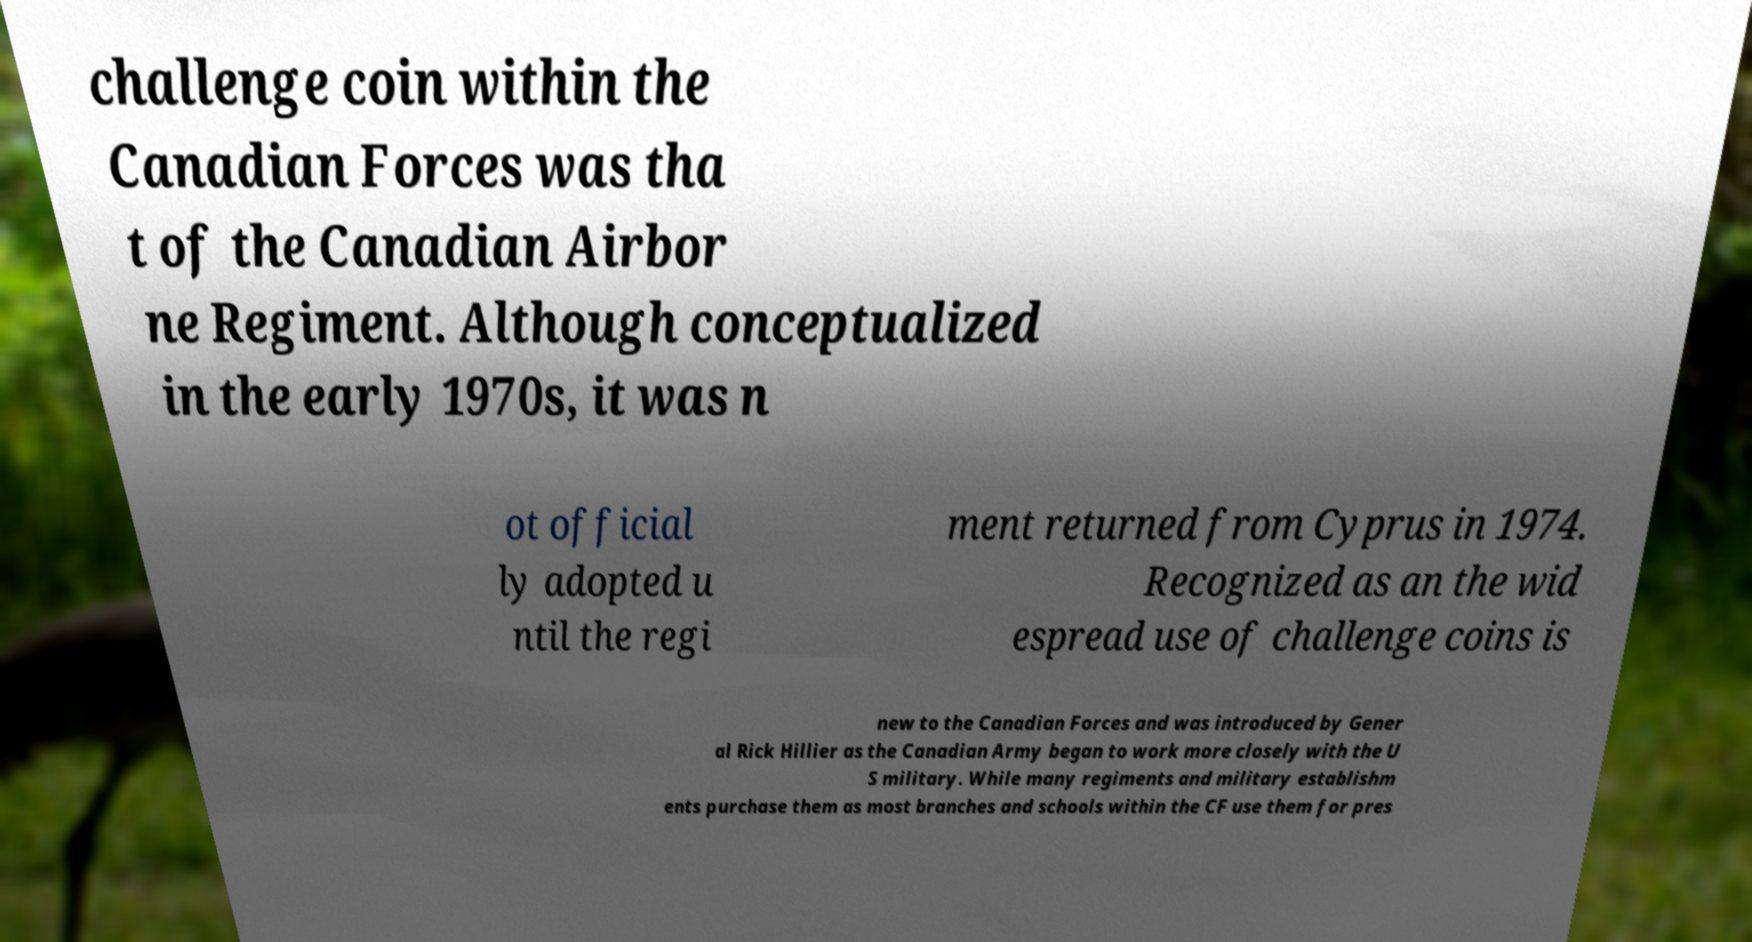Please identify and transcribe the text found in this image. challenge coin within the Canadian Forces was tha t of the Canadian Airbor ne Regiment. Although conceptualized in the early 1970s, it was n ot official ly adopted u ntil the regi ment returned from Cyprus in 1974. Recognized as an the wid espread use of challenge coins is new to the Canadian Forces and was introduced by Gener al Rick Hillier as the Canadian Army began to work more closely with the U S military. While many regiments and military establishm ents purchase them as most branches and schools within the CF use them for pres 